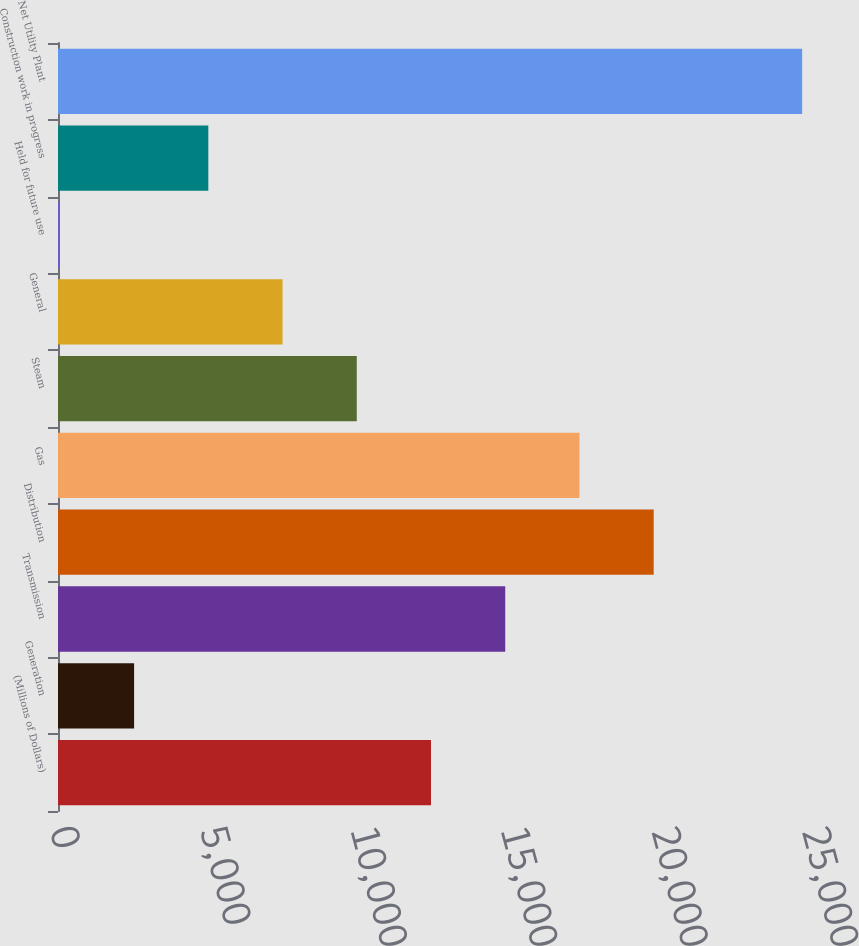Convert chart. <chart><loc_0><loc_0><loc_500><loc_500><bar_chart><fcel>(Millions of Dollars)<fcel>Generation<fcel>Transmission<fcel>Distribution<fcel>Gas<fcel>Steam<fcel>General<fcel>Held for future use<fcel>Construction work in progress<fcel>Net Utility Plant<nl><fcel>12400.5<fcel>2529.7<fcel>14868.2<fcel>19803.6<fcel>17335.9<fcel>9932.8<fcel>7465.1<fcel>62<fcel>4997.4<fcel>24739<nl></chart> 